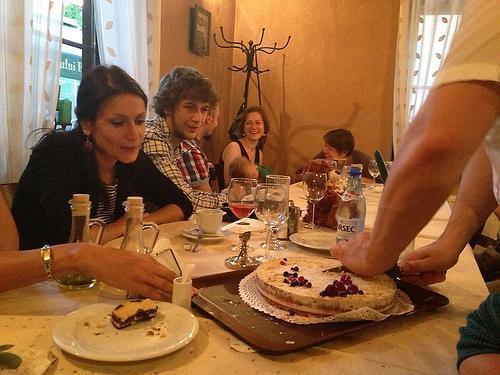How many people are in the photo?
Give a very brief answer. 8. How many windows are in the photo?
Give a very brief answer. 2. 